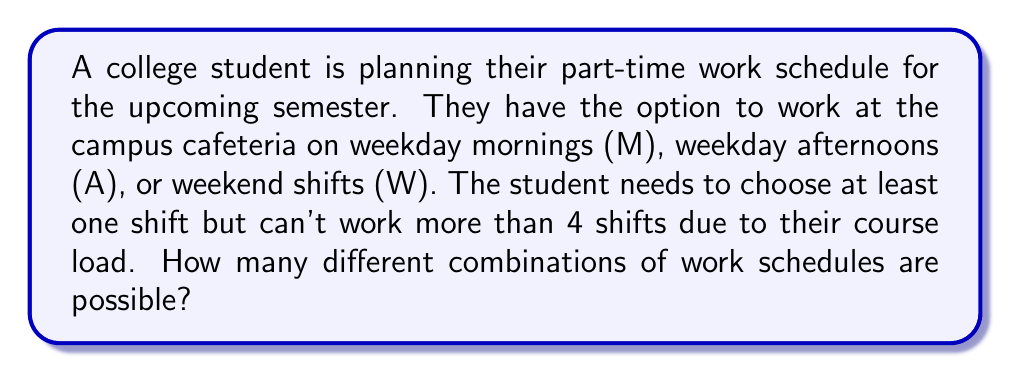What is the answer to this math problem? Let's approach this step-by-step:

1) First, we need to understand that this is a combination problem where order doesn't matter (working Monday morning and Wednesday afternoon is the same as working Wednesday afternoon and Monday morning).

2) We can use the sum of combinations formula to solve this:

   $$\sum_{k=1}^{4} \binom{3}{k}$$

   Where 3 is the number of shift options (M, A, W) and k goes from 1 to 4 (as the student must work at least 1 shift but no more than 4).

3) Let's calculate each combination:

   For k = 1: $\binom{3}{1} = 3$
   For k = 2: $\binom{3}{2} = 3$
   For k = 3: $\binom{3}{3} = 1$
   For k = 4: $\binom{3}{4} = 0$ (it's impossible to choose 4 from 3 options)

4) Now, let's sum these up:

   $$3 + 3 + 1 + 0 = 7$$

5) Therefore, there are 7 possible combinations of work schedules.

To break it down further:
- 3 ways to choose 1 shift: (M), (A), (W)
- 3 ways to choose 2 shifts: (M,A), (M,W), (A,W)
- 1 way to choose all 3 shifts: (M,A,W)
Answer: 7 combinations 